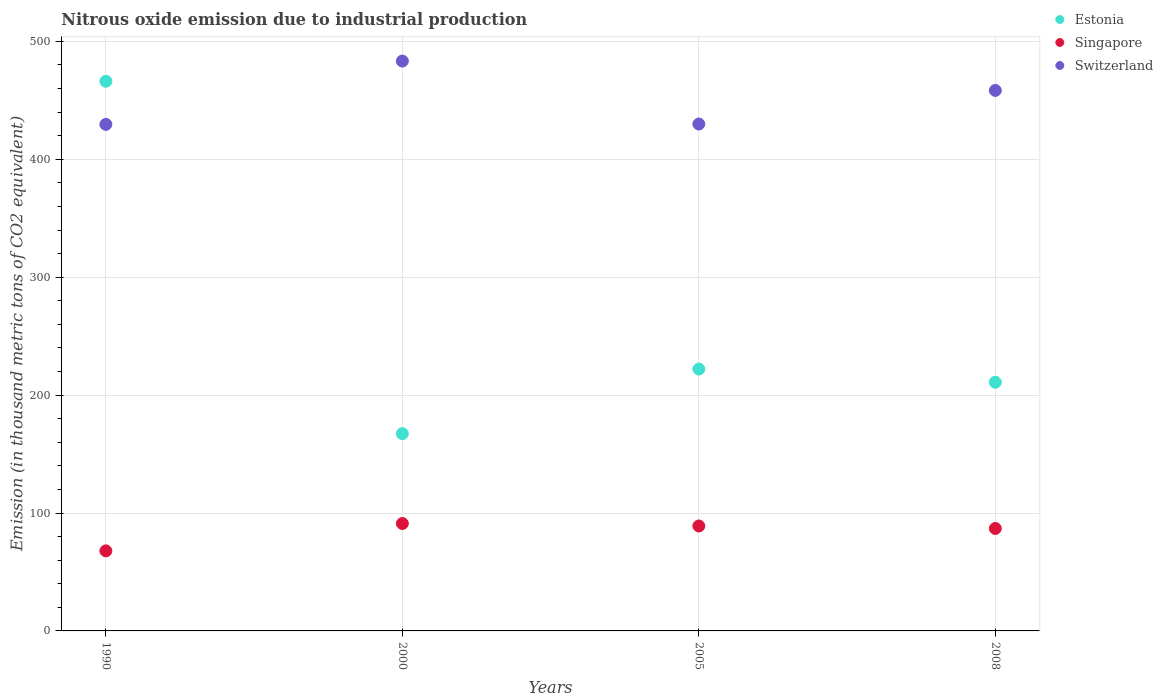Is the number of dotlines equal to the number of legend labels?
Your answer should be compact. Yes. What is the amount of nitrous oxide emitted in Singapore in 1990?
Your answer should be very brief. 67.9. Across all years, what is the maximum amount of nitrous oxide emitted in Estonia?
Provide a short and direct response. 466.2. Across all years, what is the minimum amount of nitrous oxide emitted in Singapore?
Ensure brevity in your answer.  67.9. In which year was the amount of nitrous oxide emitted in Singapore maximum?
Make the answer very short. 2000. In which year was the amount of nitrous oxide emitted in Switzerland minimum?
Provide a short and direct response. 1990. What is the total amount of nitrous oxide emitted in Switzerland in the graph?
Provide a short and direct response. 1801.2. What is the difference between the amount of nitrous oxide emitted in Switzerland in 2005 and that in 2008?
Make the answer very short. -28.5. What is the difference between the amount of nitrous oxide emitted in Singapore in 2005 and the amount of nitrous oxide emitted in Estonia in 2000?
Ensure brevity in your answer.  -78.3. What is the average amount of nitrous oxide emitted in Singapore per year?
Provide a short and direct response. 83.72. In the year 2008, what is the difference between the amount of nitrous oxide emitted in Singapore and amount of nitrous oxide emitted in Switzerland?
Ensure brevity in your answer.  -371.5. What is the ratio of the amount of nitrous oxide emitted in Singapore in 1990 to that in 2005?
Provide a succinct answer. 0.76. What is the difference between the highest and the second highest amount of nitrous oxide emitted in Estonia?
Your answer should be compact. 244.1. What is the difference between the highest and the lowest amount of nitrous oxide emitted in Switzerland?
Offer a terse response. 53.7. In how many years, is the amount of nitrous oxide emitted in Estonia greater than the average amount of nitrous oxide emitted in Estonia taken over all years?
Your response must be concise. 1. Does the amount of nitrous oxide emitted in Estonia monotonically increase over the years?
Your response must be concise. No. Is the amount of nitrous oxide emitted in Singapore strictly greater than the amount of nitrous oxide emitted in Estonia over the years?
Keep it short and to the point. No. How many dotlines are there?
Your answer should be compact. 3. What is the difference between two consecutive major ticks on the Y-axis?
Offer a very short reply. 100. Are the values on the major ticks of Y-axis written in scientific E-notation?
Provide a succinct answer. No. Does the graph contain any zero values?
Your answer should be very brief. No. Where does the legend appear in the graph?
Your answer should be compact. Top right. How are the legend labels stacked?
Provide a succinct answer. Vertical. What is the title of the graph?
Keep it short and to the point. Nitrous oxide emission due to industrial production. Does "Togo" appear as one of the legend labels in the graph?
Give a very brief answer. No. What is the label or title of the X-axis?
Provide a succinct answer. Years. What is the label or title of the Y-axis?
Offer a terse response. Emission (in thousand metric tons of CO2 equivalent). What is the Emission (in thousand metric tons of CO2 equivalent) in Estonia in 1990?
Make the answer very short. 466.2. What is the Emission (in thousand metric tons of CO2 equivalent) in Singapore in 1990?
Your answer should be very brief. 67.9. What is the Emission (in thousand metric tons of CO2 equivalent) of Switzerland in 1990?
Keep it short and to the point. 429.6. What is the Emission (in thousand metric tons of CO2 equivalent) of Estonia in 2000?
Keep it short and to the point. 167.3. What is the Emission (in thousand metric tons of CO2 equivalent) in Singapore in 2000?
Keep it short and to the point. 91.1. What is the Emission (in thousand metric tons of CO2 equivalent) of Switzerland in 2000?
Offer a terse response. 483.3. What is the Emission (in thousand metric tons of CO2 equivalent) in Estonia in 2005?
Offer a terse response. 222.1. What is the Emission (in thousand metric tons of CO2 equivalent) in Singapore in 2005?
Provide a succinct answer. 89. What is the Emission (in thousand metric tons of CO2 equivalent) in Switzerland in 2005?
Your answer should be very brief. 429.9. What is the Emission (in thousand metric tons of CO2 equivalent) in Estonia in 2008?
Offer a terse response. 210.9. What is the Emission (in thousand metric tons of CO2 equivalent) of Singapore in 2008?
Your answer should be compact. 86.9. What is the Emission (in thousand metric tons of CO2 equivalent) in Switzerland in 2008?
Make the answer very short. 458.4. Across all years, what is the maximum Emission (in thousand metric tons of CO2 equivalent) in Estonia?
Give a very brief answer. 466.2. Across all years, what is the maximum Emission (in thousand metric tons of CO2 equivalent) in Singapore?
Your answer should be very brief. 91.1. Across all years, what is the maximum Emission (in thousand metric tons of CO2 equivalent) in Switzerland?
Your response must be concise. 483.3. Across all years, what is the minimum Emission (in thousand metric tons of CO2 equivalent) in Estonia?
Keep it short and to the point. 167.3. Across all years, what is the minimum Emission (in thousand metric tons of CO2 equivalent) of Singapore?
Make the answer very short. 67.9. Across all years, what is the minimum Emission (in thousand metric tons of CO2 equivalent) of Switzerland?
Keep it short and to the point. 429.6. What is the total Emission (in thousand metric tons of CO2 equivalent) in Estonia in the graph?
Your answer should be compact. 1066.5. What is the total Emission (in thousand metric tons of CO2 equivalent) of Singapore in the graph?
Give a very brief answer. 334.9. What is the total Emission (in thousand metric tons of CO2 equivalent) of Switzerland in the graph?
Give a very brief answer. 1801.2. What is the difference between the Emission (in thousand metric tons of CO2 equivalent) in Estonia in 1990 and that in 2000?
Your answer should be compact. 298.9. What is the difference between the Emission (in thousand metric tons of CO2 equivalent) of Singapore in 1990 and that in 2000?
Keep it short and to the point. -23.2. What is the difference between the Emission (in thousand metric tons of CO2 equivalent) in Switzerland in 1990 and that in 2000?
Give a very brief answer. -53.7. What is the difference between the Emission (in thousand metric tons of CO2 equivalent) of Estonia in 1990 and that in 2005?
Your answer should be compact. 244.1. What is the difference between the Emission (in thousand metric tons of CO2 equivalent) in Singapore in 1990 and that in 2005?
Your answer should be compact. -21.1. What is the difference between the Emission (in thousand metric tons of CO2 equivalent) of Estonia in 1990 and that in 2008?
Make the answer very short. 255.3. What is the difference between the Emission (in thousand metric tons of CO2 equivalent) of Switzerland in 1990 and that in 2008?
Make the answer very short. -28.8. What is the difference between the Emission (in thousand metric tons of CO2 equivalent) in Estonia in 2000 and that in 2005?
Keep it short and to the point. -54.8. What is the difference between the Emission (in thousand metric tons of CO2 equivalent) of Switzerland in 2000 and that in 2005?
Offer a very short reply. 53.4. What is the difference between the Emission (in thousand metric tons of CO2 equivalent) in Estonia in 2000 and that in 2008?
Give a very brief answer. -43.6. What is the difference between the Emission (in thousand metric tons of CO2 equivalent) of Singapore in 2000 and that in 2008?
Make the answer very short. 4.2. What is the difference between the Emission (in thousand metric tons of CO2 equivalent) of Switzerland in 2000 and that in 2008?
Your response must be concise. 24.9. What is the difference between the Emission (in thousand metric tons of CO2 equivalent) of Estonia in 2005 and that in 2008?
Keep it short and to the point. 11.2. What is the difference between the Emission (in thousand metric tons of CO2 equivalent) of Singapore in 2005 and that in 2008?
Ensure brevity in your answer.  2.1. What is the difference between the Emission (in thousand metric tons of CO2 equivalent) of Switzerland in 2005 and that in 2008?
Keep it short and to the point. -28.5. What is the difference between the Emission (in thousand metric tons of CO2 equivalent) of Estonia in 1990 and the Emission (in thousand metric tons of CO2 equivalent) of Singapore in 2000?
Your answer should be compact. 375.1. What is the difference between the Emission (in thousand metric tons of CO2 equivalent) of Estonia in 1990 and the Emission (in thousand metric tons of CO2 equivalent) of Switzerland in 2000?
Provide a succinct answer. -17.1. What is the difference between the Emission (in thousand metric tons of CO2 equivalent) of Singapore in 1990 and the Emission (in thousand metric tons of CO2 equivalent) of Switzerland in 2000?
Your answer should be compact. -415.4. What is the difference between the Emission (in thousand metric tons of CO2 equivalent) of Estonia in 1990 and the Emission (in thousand metric tons of CO2 equivalent) of Singapore in 2005?
Your answer should be very brief. 377.2. What is the difference between the Emission (in thousand metric tons of CO2 equivalent) of Estonia in 1990 and the Emission (in thousand metric tons of CO2 equivalent) of Switzerland in 2005?
Your response must be concise. 36.3. What is the difference between the Emission (in thousand metric tons of CO2 equivalent) of Singapore in 1990 and the Emission (in thousand metric tons of CO2 equivalent) of Switzerland in 2005?
Keep it short and to the point. -362. What is the difference between the Emission (in thousand metric tons of CO2 equivalent) in Estonia in 1990 and the Emission (in thousand metric tons of CO2 equivalent) in Singapore in 2008?
Provide a succinct answer. 379.3. What is the difference between the Emission (in thousand metric tons of CO2 equivalent) in Singapore in 1990 and the Emission (in thousand metric tons of CO2 equivalent) in Switzerland in 2008?
Keep it short and to the point. -390.5. What is the difference between the Emission (in thousand metric tons of CO2 equivalent) of Estonia in 2000 and the Emission (in thousand metric tons of CO2 equivalent) of Singapore in 2005?
Offer a very short reply. 78.3. What is the difference between the Emission (in thousand metric tons of CO2 equivalent) of Estonia in 2000 and the Emission (in thousand metric tons of CO2 equivalent) of Switzerland in 2005?
Your answer should be compact. -262.6. What is the difference between the Emission (in thousand metric tons of CO2 equivalent) of Singapore in 2000 and the Emission (in thousand metric tons of CO2 equivalent) of Switzerland in 2005?
Provide a succinct answer. -338.8. What is the difference between the Emission (in thousand metric tons of CO2 equivalent) of Estonia in 2000 and the Emission (in thousand metric tons of CO2 equivalent) of Singapore in 2008?
Offer a very short reply. 80.4. What is the difference between the Emission (in thousand metric tons of CO2 equivalent) of Estonia in 2000 and the Emission (in thousand metric tons of CO2 equivalent) of Switzerland in 2008?
Ensure brevity in your answer.  -291.1. What is the difference between the Emission (in thousand metric tons of CO2 equivalent) in Singapore in 2000 and the Emission (in thousand metric tons of CO2 equivalent) in Switzerland in 2008?
Provide a short and direct response. -367.3. What is the difference between the Emission (in thousand metric tons of CO2 equivalent) in Estonia in 2005 and the Emission (in thousand metric tons of CO2 equivalent) in Singapore in 2008?
Offer a terse response. 135.2. What is the difference between the Emission (in thousand metric tons of CO2 equivalent) in Estonia in 2005 and the Emission (in thousand metric tons of CO2 equivalent) in Switzerland in 2008?
Ensure brevity in your answer.  -236.3. What is the difference between the Emission (in thousand metric tons of CO2 equivalent) of Singapore in 2005 and the Emission (in thousand metric tons of CO2 equivalent) of Switzerland in 2008?
Provide a succinct answer. -369.4. What is the average Emission (in thousand metric tons of CO2 equivalent) in Estonia per year?
Provide a short and direct response. 266.62. What is the average Emission (in thousand metric tons of CO2 equivalent) in Singapore per year?
Your response must be concise. 83.72. What is the average Emission (in thousand metric tons of CO2 equivalent) of Switzerland per year?
Provide a short and direct response. 450.3. In the year 1990, what is the difference between the Emission (in thousand metric tons of CO2 equivalent) in Estonia and Emission (in thousand metric tons of CO2 equivalent) in Singapore?
Your answer should be compact. 398.3. In the year 1990, what is the difference between the Emission (in thousand metric tons of CO2 equivalent) of Estonia and Emission (in thousand metric tons of CO2 equivalent) of Switzerland?
Give a very brief answer. 36.6. In the year 1990, what is the difference between the Emission (in thousand metric tons of CO2 equivalent) in Singapore and Emission (in thousand metric tons of CO2 equivalent) in Switzerland?
Keep it short and to the point. -361.7. In the year 2000, what is the difference between the Emission (in thousand metric tons of CO2 equivalent) in Estonia and Emission (in thousand metric tons of CO2 equivalent) in Singapore?
Make the answer very short. 76.2. In the year 2000, what is the difference between the Emission (in thousand metric tons of CO2 equivalent) in Estonia and Emission (in thousand metric tons of CO2 equivalent) in Switzerland?
Your answer should be compact. -316. In the year 2000, what is the difference between the Emission (in thousand metric tons of CO2 equivalent) of Singapore and Emission (in thousand metric tons of CO2 equivalent) of Switzerland?
Offer a very short reply. -392.2. In the year 2005, what is the difference between the Emission (in thousand metric tons of CO2 equivalent) of Estonia and Emission (in thousand metric tons of CO2 equivalent) of Singapore?
Provide a short and direct response. 133.1. In the year 2005, what is the difference between the Emission (in thousand metric tons of CO2 equivalent) of Estonia and Emission (in thousand metric tons of CO2 equivalent) of Switzerland?
Keep it short and to the point. -207.8. In the year 2005, what is the difference between the Emission (in thousand metric tons of CO2 equivalent) of Singapore and Emission (in thousand metric tons of CO2 equivalent) of Switzerland?
Provide a succinct answer. -340.9. In the year 2008, what is the difference between the Emission (in thousand metric tons of CO2 equivalent) in Estonia and Emission (in thousand metric tons of CO2 equivalent) in Singapore?
Your answer should be very brief. 124. In the year 2008, what is the difference between the Emission (in thousand metric tons of CO2 equivalent) in Estonia and Emission (in thousand metric tons of CO2 equivalent) in Switzerland?
Your answer should be compact. -247.5. In the year 2008, what is the difference between the Emission (in thousand metric tons of CO2 equivalent) in Singapore and Emission (in thousand metric tons of CO2 equivalent) in Switzerland?
Ensure brevity in your answer.  -371.5. What is the ratio of the Emission (in thousand metric tons of CO2 equivalent) of Estonia in 1990 to that in 2000?
Your answer should be very brief. 2.79. What is the ratio of the Emission (in thousand metric tons of CO2 equivalent) in Singapore in 1990 to that in 2000?
Offer a very short reply. 0.75. What is the ratio of the Emission (in thousand metric tons of CO2 equivalent) in Estonia in 1990 to that in 2005?
Provide a succinct answer. 2.1. What is the ratio of the Emission (in thousand metric tons of CO2 equivalent) in Singapore in 1990 to that in 2005?
Your response must be concise. 0.76. What is the ratio of the Emission (in thousand metric tons of CO2 equivalent) of Switzerland in 1990 to that in 2005?
Offer a terse response. 1. What is the ratio of the Emission (in thousand metric tons of CO2 equivalent) in Estonia in 1990 to that in 2008?
Offer a terse response. 2.21. What is the ratio of the Emission (in thousand metric tons of CO2 equivalent) of Singapore in 1990 to that in 2008?
Your answer should be compact. 0.78. What is the ratio of the Emission (in thousand metric tons of CO2 equivalent) of Switzerland in 1990 to that in 2008?
Provide a short and direct response. 0.94. What is the ratio of the Emission (in thousand metric tons of CO2 equivalent) of Estonia in 2000 to that in 2005?
Your answer should be very brief. 0.75. What is the ratio of the Emission (in thousand metric tons of CO2 equivalent) in Singapore in 2000 to that in 2005?
Give a very brief answer. 1.02. What is the ratio of the Emission (in thousand metric tons of CO2 equivalent) of Switzerland in 2000 to that in 2005?
Your answer should be compact. 1.12. What is the ratio of the Emission (in thousand metric tons of CO2 equivalent) in Estonia in 2000 to that in 2008?
Provide a short and direct response. 0.79. What is the ratio of the Emission (in thousand metric tons of CO2 equivalent) in Singapore in 2000 to that in 2008?
Provide a succinct answer. 1.05. What is the ratio of the Emission (in thousand metric tons of CO2 equivalent) in Switzerland in 2000 to that in 2008?
Your response must be concise. 1.05. What is the ratio of the Emission (in thousand metric tons of CO2 equivalent) in Estonia in 2005 to that in 2008?
Offer a terse response. 1.05. What is the ratio of the Emission (in thousand metric tons of CO2 equivalent) of Singapore in 2005 to that in 2008?
Offer a terse response. 1.02. What is the ratio of the Emission (in thousand metric tons of CO2 equivalent) of Switzerland in 2005 to that in 2008?
Offer a terse response. 0.94. What is the difference between the highest and the second highest Emission (in thousand metric tons of CO2 equivalent) of Estonia?
Ensure brevity in your answer.  244.1. What is the difference between the highest and the second highest Emission (in thousand metric tons of CO2 equivalent) of Singapore?
Keep it short and to the point. 2.1. What is the difference between the highest and the second highest Emission (in thousand metric tons of CO2 equivalent) in Switzerland?
Make the answer very short. 24.9. What is the difference between the highest and the lowest Emission (in thousand metric tons of CO2 equivalent) in Estonia?
Your response must be concise. 298.9. What is the difference between the highest and the lowest Emission (in thousand metric tons of CO2 equivalent) of Singapore?
Keep it short and to the point. 23.2. What is the difference between the highest and the lowest Emission (in thousand metric tons of CO2 equivalent) of Switzerland?
Provide a succinct answer. 53.7. 